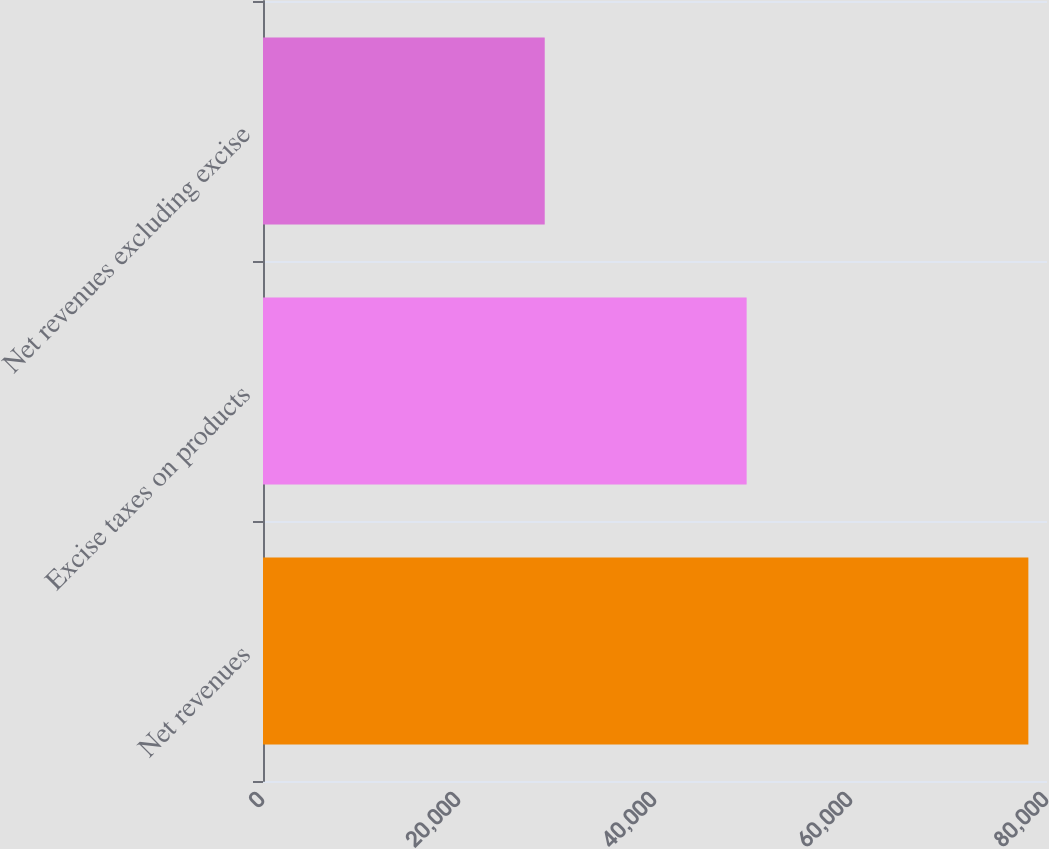Convert chart. <chart><loc_0><loc_0><loc_500><loc_500><bar_chart><fcel>Net revenues<fcel>Excise taxes on products<fcel>Net revenues excluding excise<nl><fcel>78098<fcel>49350<fcel>28748<nl></chart> 